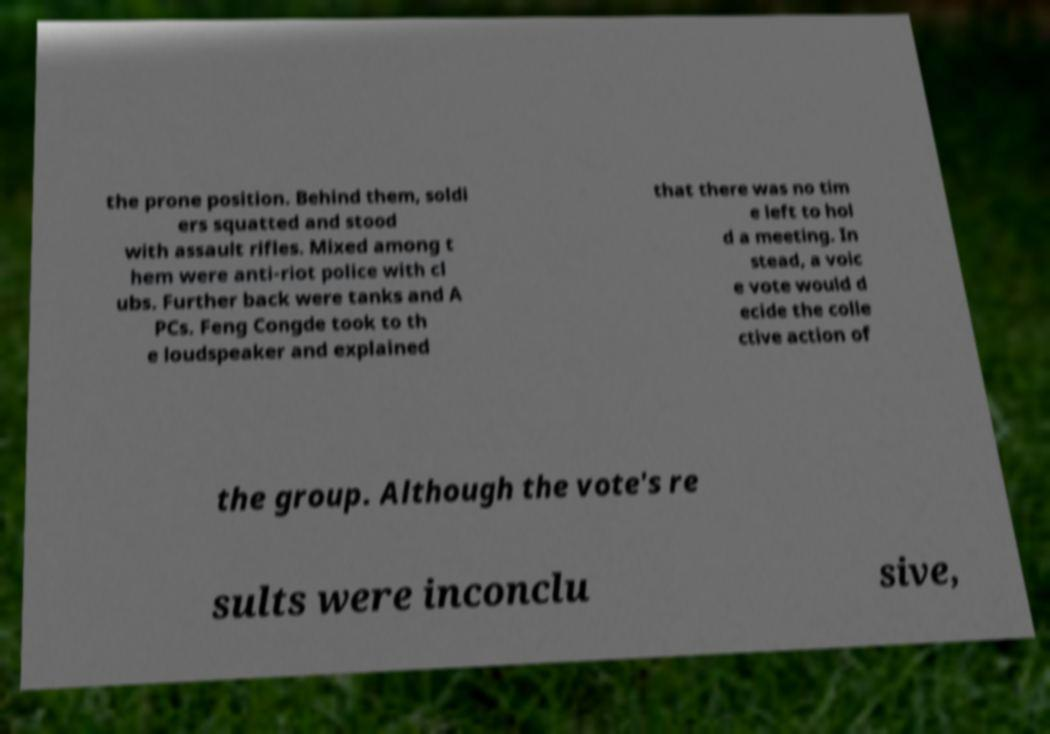I need the written content from this picture converted into text. Can you do that? the prone position. Behind them, soldi ers squatted and stood with assault rifles. Mixed among t hem were anti-riot police with cl ubs. Further back were tanks and A PCs. Feng Congde took to th e loudspeaker and explained that there was no tim e left to hol d a meeting. In stead, a voic e vote would d ecide the colle ctive action of the group. Although the vote's re sults were inconclu sive, 